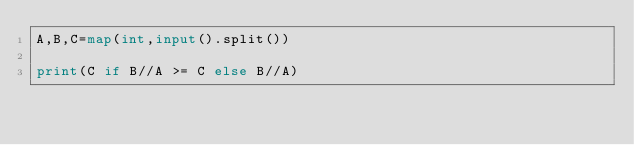Convert code to text. <code><loc_0><loc_0><loc_500><loc_500><_Python_>A,B,C=map(int,input().split())

print(C if B//A >= C else B//A)</code> 